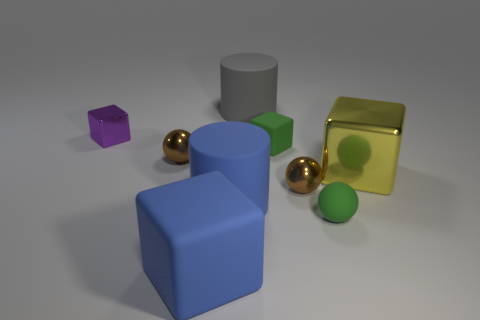Can you describe the lighting in the scene? The scene is illuminated by a soft, diffuse overhead light, casting gentle shadows beneath each object. There is a balance of light that suggests an indoor setting with ambient lighting designed to minimize harsh reflections and enhance visibility. 